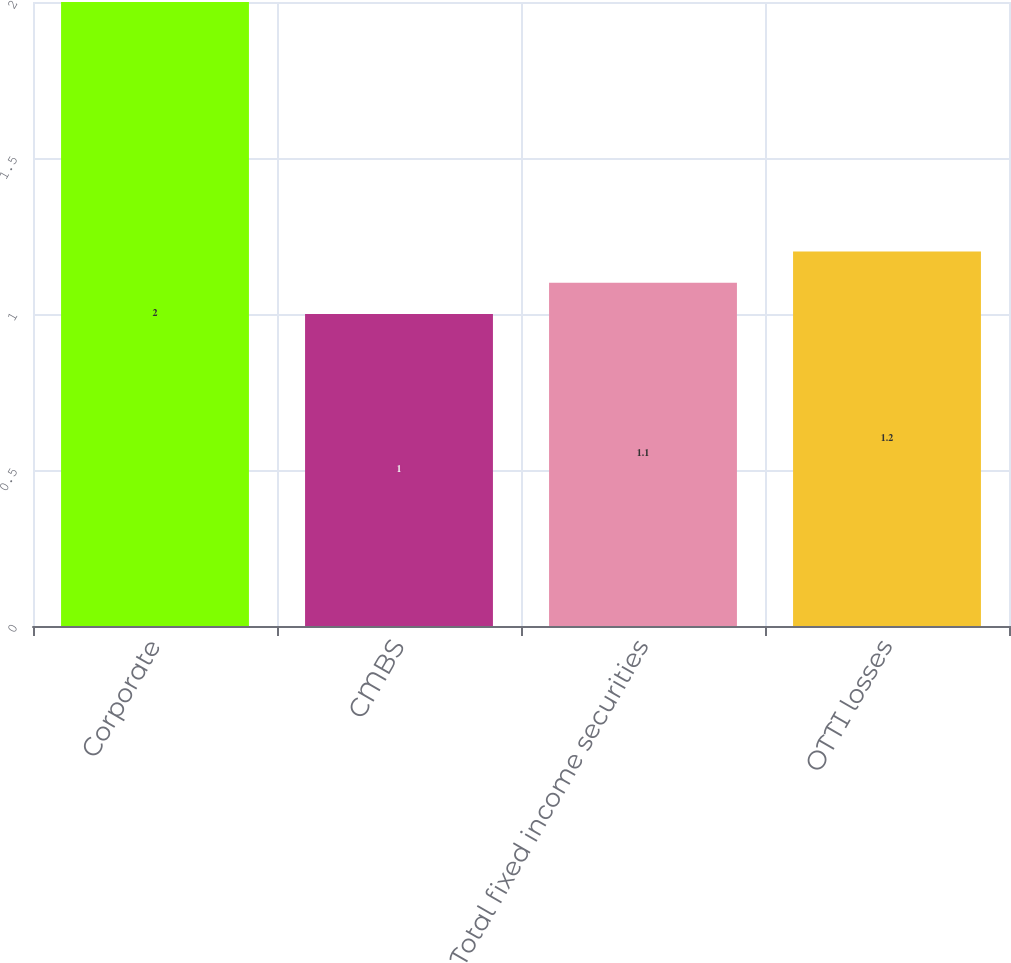Convert chart to OTSL. <chart><loc_0><loc_0><loc_500><loc_500><bar_chart><fcel>Corporate<fcel>CMBS<fcel>Total fixed income securities<fcel>OTTI losses<nl><fcel>2<fcel>1<fcel>1.1<fcel>1.2<nl></chart> 